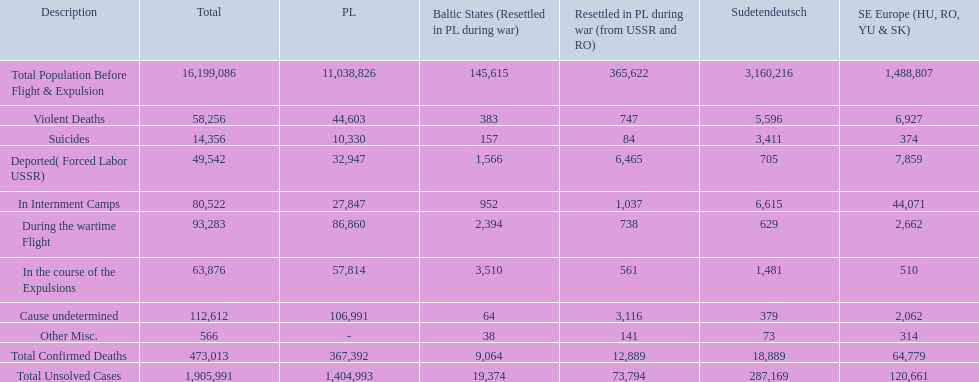How many total confirmed deaths were there in the baltic states? 9,064. How many deaths had an undetermined cause? 64. How many deaths in that region were miscellaneous? 38. Were there more deaths from an undetermined cause or that were listed as miscellaneous? Cause undetermined. 